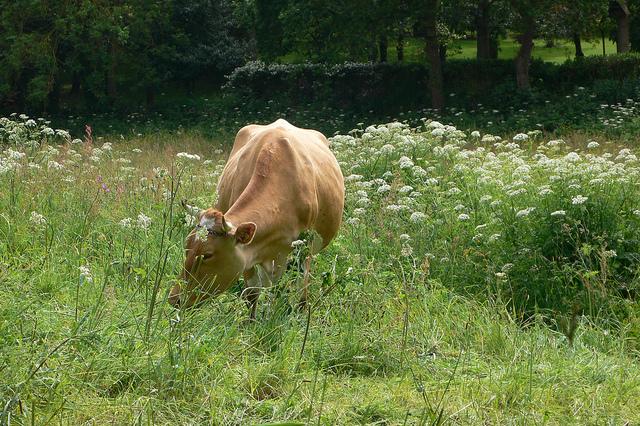What color flowers do you see?
Keep it brief. White. What is the cow eating?
Answer briefly. Grass. What color is the animal?
Write a very short answer. Brown. What color are the flowers?
Quick response, please. White. How many cows are in the photo?
Keep it brief. 1. What kind of flower is growing in the grass?
Answer briefly. Daisy. 